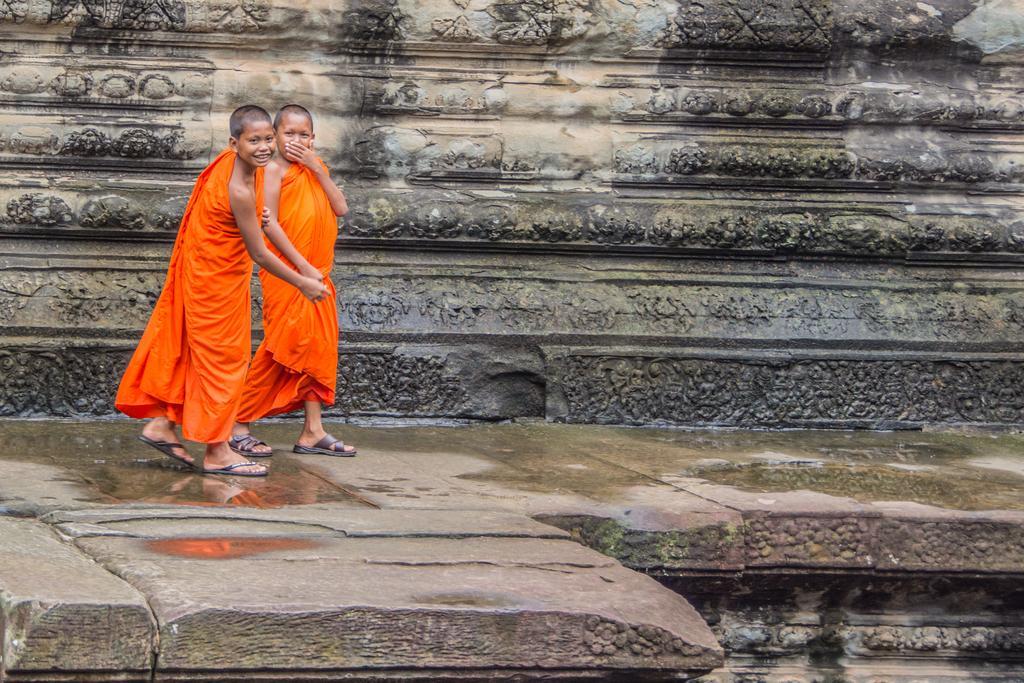How would you summarize this image in a sentence or two? In this image there are two monks walking with a smile on their face, behind them there is a rock. 